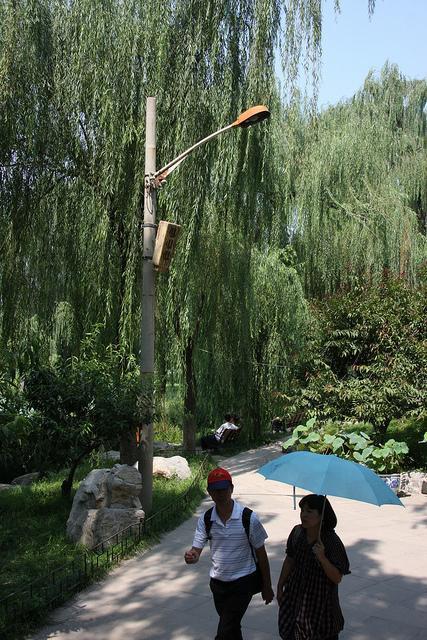How many people are there?
Give a very brief answer. 2. 